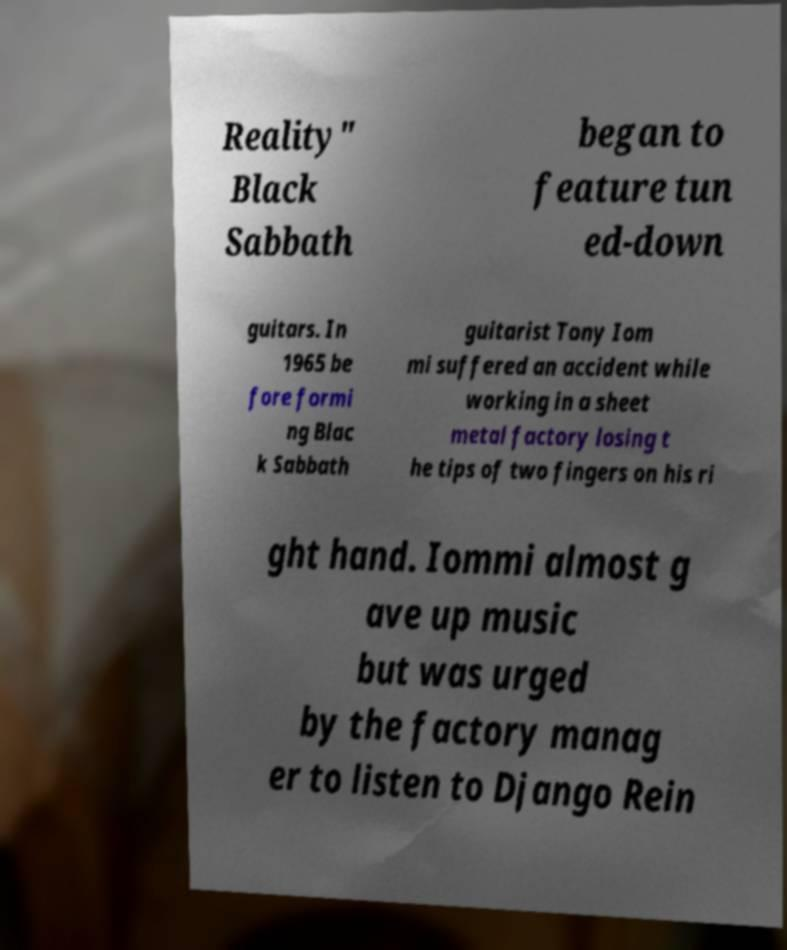Please identify and transcribe the text found in this image. Reality" Black Sabbath began to feature tun ed-down guitars. In 1965 be fore formi ng Blac k Sabbath guitarist Tony Iom mi suffered an accident while working in a sheet metal factory losing t he tips of two fingers on his ri ght hand. Iommi almost g ave up music but was urged by the factory manag er to listen to Django Rein 